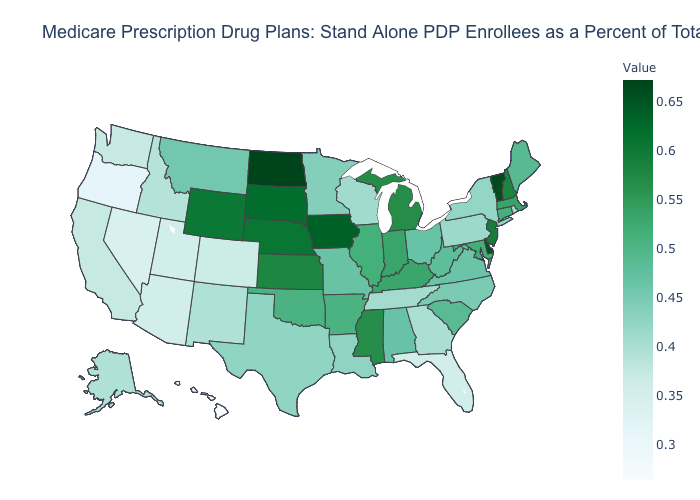Is the legend a continuous bar?
Short answer required. Yes. Does Georgia have the lowest value in the USA?
Give a very brief answer. No. Among the states that border Maryland , which have the highest value?
Quick response, please. Delaware. Does Maine have the highest value in the USA?
Quick response, please. No. Does Florida have the lowest value in the South?
Write a very short answer. Yes. Among the states that border Minnesota , does North Dakota have the highest value?
Write a very short answer. Yes. Which states hav the highest value in the West?
Quick response, please. Wyoming. Which states hav the highest value in the West?
Write a very short answer. Wyoming. 